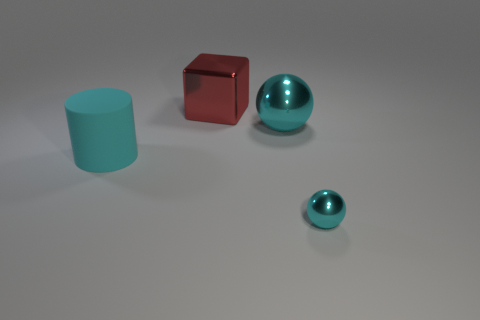How many other objects are the same color as the large matte cylinder?
Your response must be concise. 2. What number of objects are either red cubes or cyan things that are on the left side of the large cyan shiny thing?
Your answer should be very brief. 2. There is a large ball; is it the same color as the big thing behind the large cyan metal sphere?
Provide a short and direct response. No. There is a cyan thing that is in front of the large cyan metal object and to the right of the matte object; how big is it?
Provide a succinct answer. Small. Are there any big shiny objects in front of the red object?
Provide a short and direct response. Yes. There is a thing left of the red shiny block; is there a cylinder that is on the left side of it?
Your answer should be compact. No. Are there an equal number of tiny cyan shiny balls behind the large block and big red objects that are in front of the big ball?
Provide a succinct answer. Yes. The tiny sphere that is the same material as the large block is what color?
Ensure brevity in your answer.  Cyan. Are there any spheres that have the same material as the large block?
Make the answer very short. Yes. What number of objects are either large cyan balls or cyan metallic objects?
Your answer should be compact. 2. 